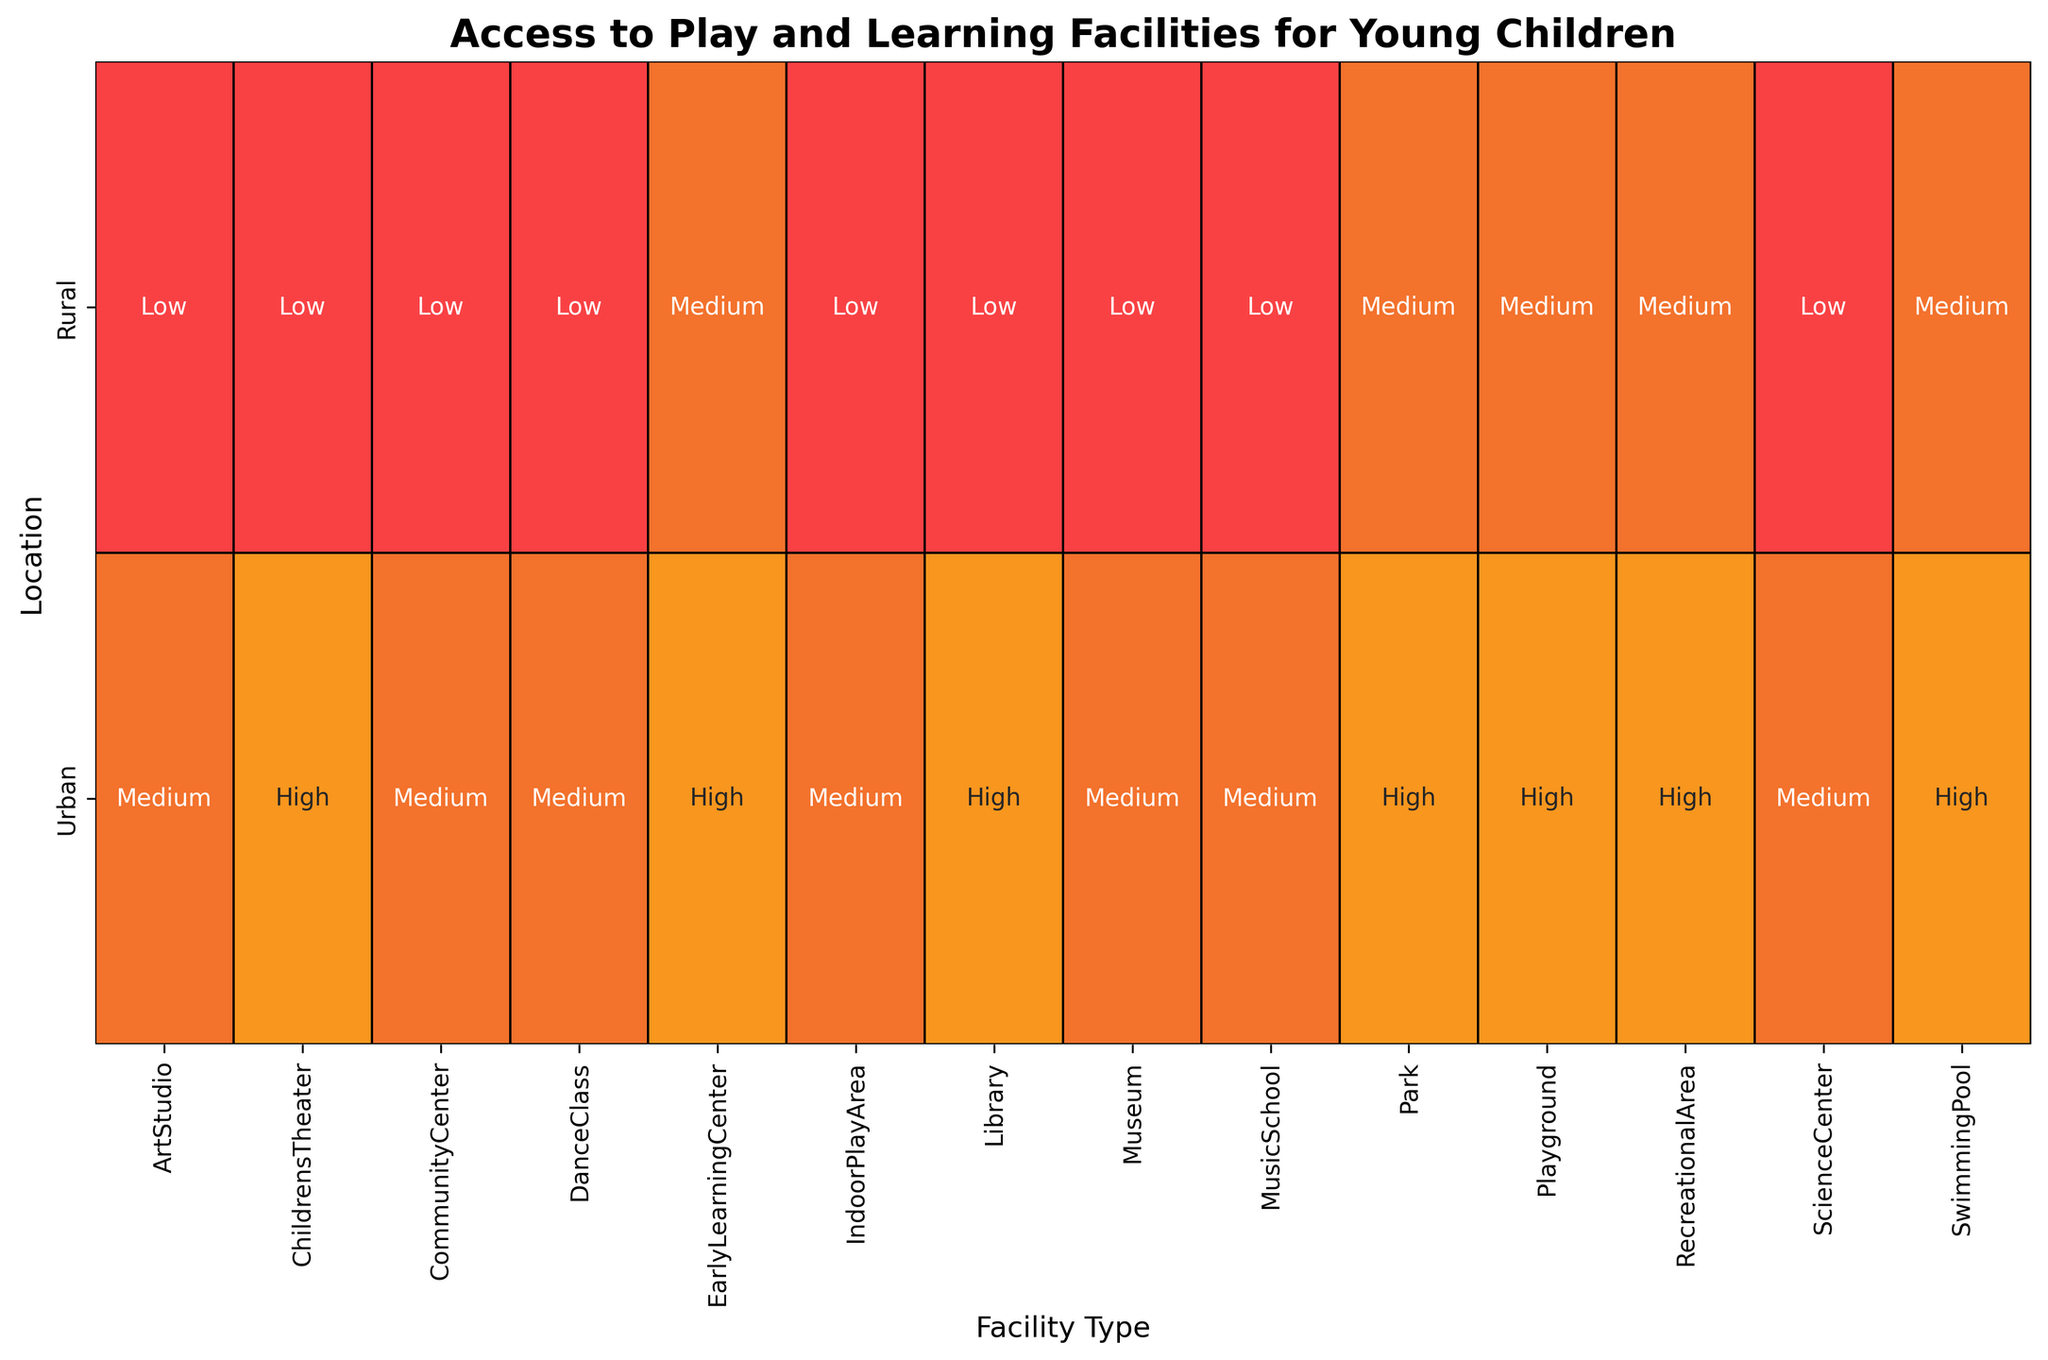What type of facility in urban areas has the lowest access level? First, look at all facility types listed under "Urban." The access levels are 'High', 'High', 'Medium', 'Medium', 'High', 'High', 'Medium', 'High', 'Medium', 'Medium', 'High', 'Medium', 'Medium', and 'High'. Therefore, the lowest access level is 'Medium', which applies to Community Center, Museum, Indoor Play Area, Music School, Dance Class, Science Center, and Art Studio.
Answer: Community Center, Museum, Indoor Play Area, Music School, Dance Class, Science Center, Art Studio Which facility type has the same access level in both urban and rural areas? Identify the access levels for each facility type in both urban and rural areas and look for matches. For the 'Playground' type, both urban and rural areas have an access level of 'High' and 'Medium', respectively. No other facility has the same levels across both areas.
Answer: None How many facilities in rural areas have a high access level? Look up all facility types listed under "Rural" and check their access levels. The access level for all rural facilities ('Park', 'Library', 'Community Center', 'Museum', 'Early Learning Center', 'Recreational Area', 'Indoor Play Area', 'Playground', 'Music School', 'Dance Class', 'Swimming Pool', 'Science Center', 'Children's Theater', 'Art Studio') contains 'Low', 'Medium'. No levels are 'High'.
Answer: 0 Which location—urban or rural—has overall better access to facilities? Compare the sum of the access levels (High=3, Medium=2, Low=1) for both locations. Urban has a higher accumulation with several 'High' access levels, whereas rural predominantly exhibits 'Low' and 'Medium' levels.
Answer: Urban What visual colors and patterns indicate lower access levels? Observing the heatmap, identify the color associated with ‘Low’ access levels. These are indicated by the color mapped to the lowest number, which is red.
Answer: Red Compare the access levels of Early Learning Centers in urban versus rural areas? Locate Early Learning Center in both urban and rural sections of the heatmap. Urban's level is 'High', and rural's level is 'Medium'. Thus, urban areas have better access.
Answer: Urban has better access For which facilities do urban areas have a medium access level? Identify facilities under "Urban" and observe their access levels. Community Center, Museum, Indoor Play Area, Music School, Dance Class, Science Center, and Art Studio are listed as 'Medium'.
Answer: Community Center, Museum, Indoor Play Area, Music School, Dance Class, Science Center, Art Studio 